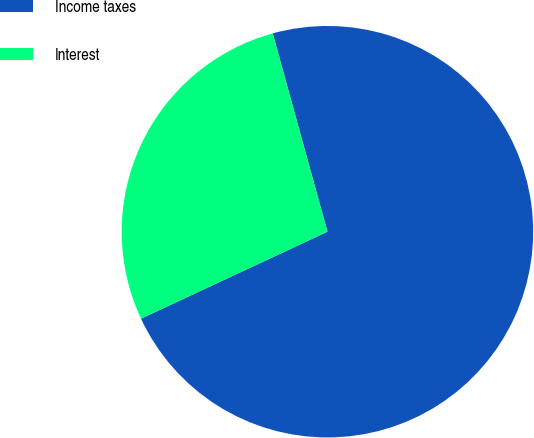Convert chart to OTSL. <chart><loc_0><loc_0><loc_500><loc_500><pie_chart><fcel>Income taxes<fcel>Interest<nl><fcel>72.34%<fcel>27.66%<nl></chart> 